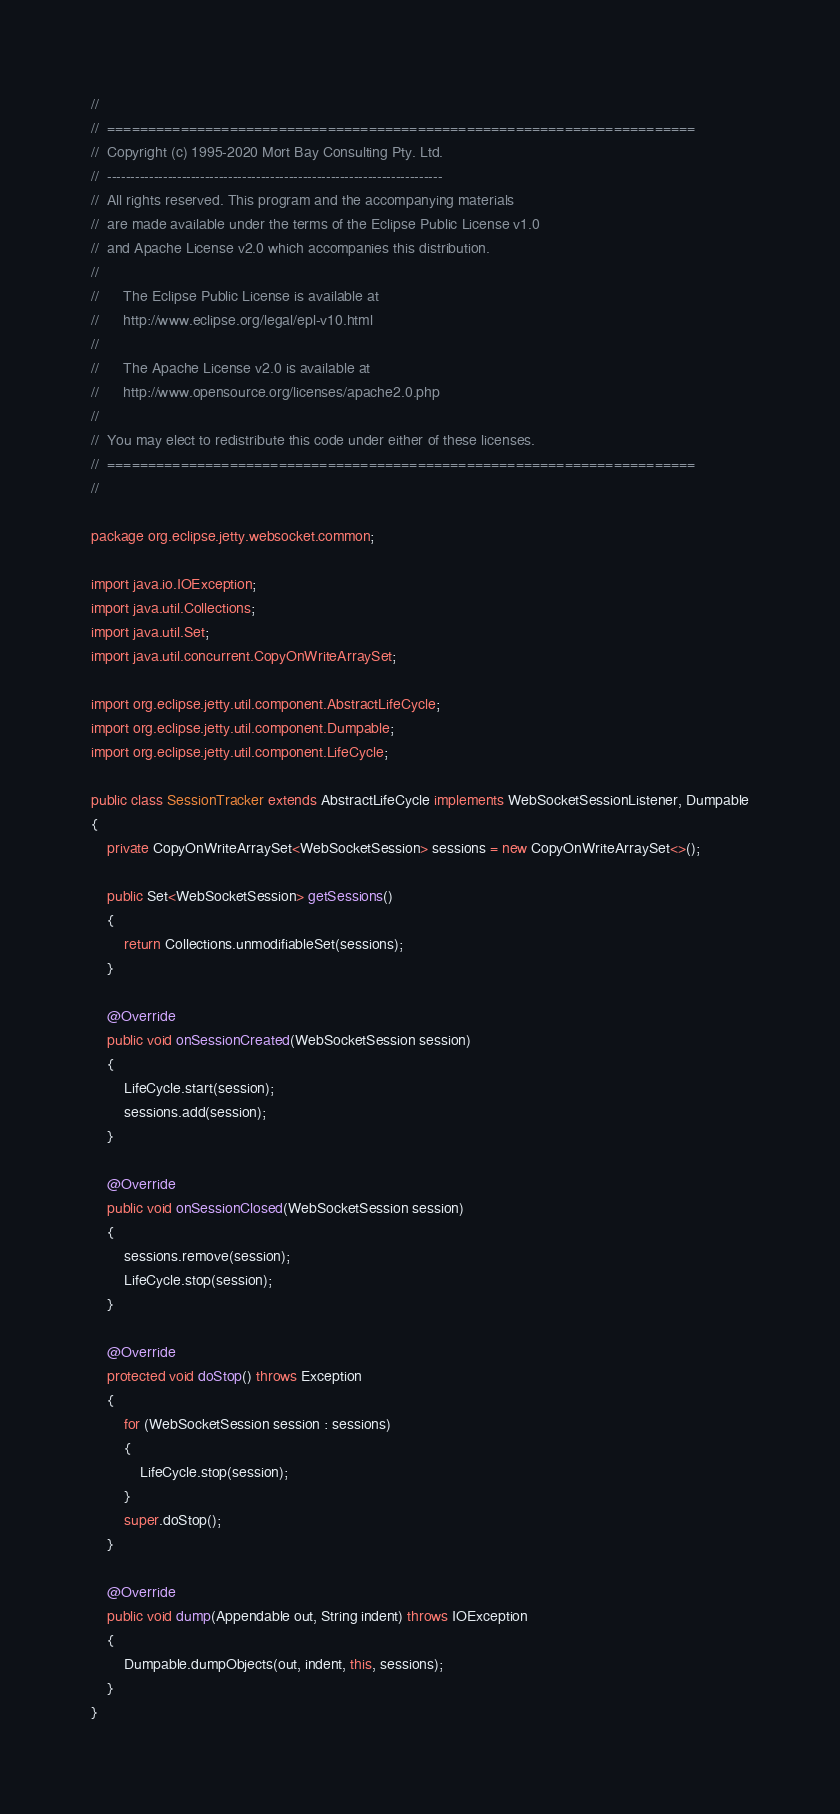Convert code to text. <code><loc_0><loc_0><loc_500><loc_500><_Java_>//
//  ========================================================================
//  Copyright (c) 1995-2020 Mort Bay Consulting Pty. Ltd.
//  ------------------------------------------------------------------------
//  All rights reserved. This program and the accompanying materials
//  are made available under the terms of the Eclipse Public License v1.0
//  and Apache License v2.0 which accompanies this distribution.
//
//      The Eclipse Public License is available at
//      http://www.eclipse.org/legal/epl-v10.html
//
//      The Apache License v2.0 is available at
//      http://www.opensource.org/licenses/apache2.0.php
//
//  You may elect to redistribute this code under either of these licenses.
//  ========================================================================
//

package org.eclipse.jetty.websocket.common;

import java.io.IOException;
import java.util.Collections;
import java.util.Set;
import java.util.concurrent.CopyOnWriteArraySet;

import org.eclipse.jetty.util.component.AbstractLifeCycle;
import org.eclipse.jetty.util.component.Dumpable;
import org.eclipse.jetty.util.component.LifeCycle;

public class SessionTracker extends AbstractLifeCycle implements WebSocketSessionListener, Dumpable
{
    private CopyOnWriteArraySet<WebSocketSession> sessions = new CopyOnWriteArraySet<>();

    public Set<WebSocketSession> getSessions()
    {
        return Collections.unmodifiableSet(sessions);
    }

    @Override
    public void onSessionCreated(WebSocketSession session)
    {
        LifeCycle.start(session);
        sessions.add(session);
    }

    @Override
    public void onSessionClosed(WebSocketSession session)
    {
        sessions.remove(session);
        LifeCycle.stop(session);
    }

    @Override
    protected void doStop() throws Exception
    {
        for (WebSocketSession session : sessions)
        {
            LifeCycle.stop(session);
        }
        super.doStop();
    }

    @Override
    public void dump(Appendable out, String indent) throws IOException
    {
        Dumpable.dumpObjects(out, indent, this, sessions);
    }
}
</code> 